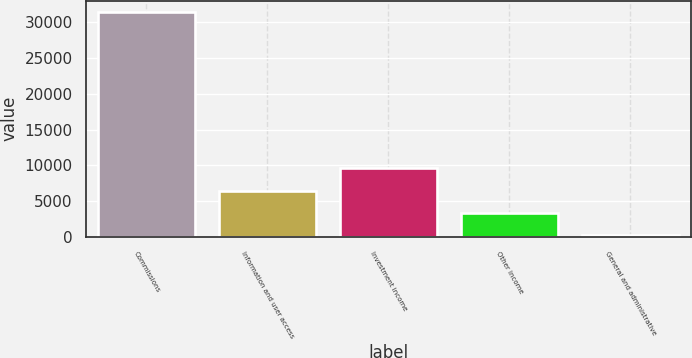Convert chart. <chart><loc_0><loc_0><loc_500><loc_500><bar_chart><fcel>Commissions<fcel>Information and user access<fcel>Investment income<fcel>Other income<fcel>General and administrative<nl><fcel>31442<fcel>6454<fcel>9577.5<fcel>3330.5<fcel>207<nl></chart> 